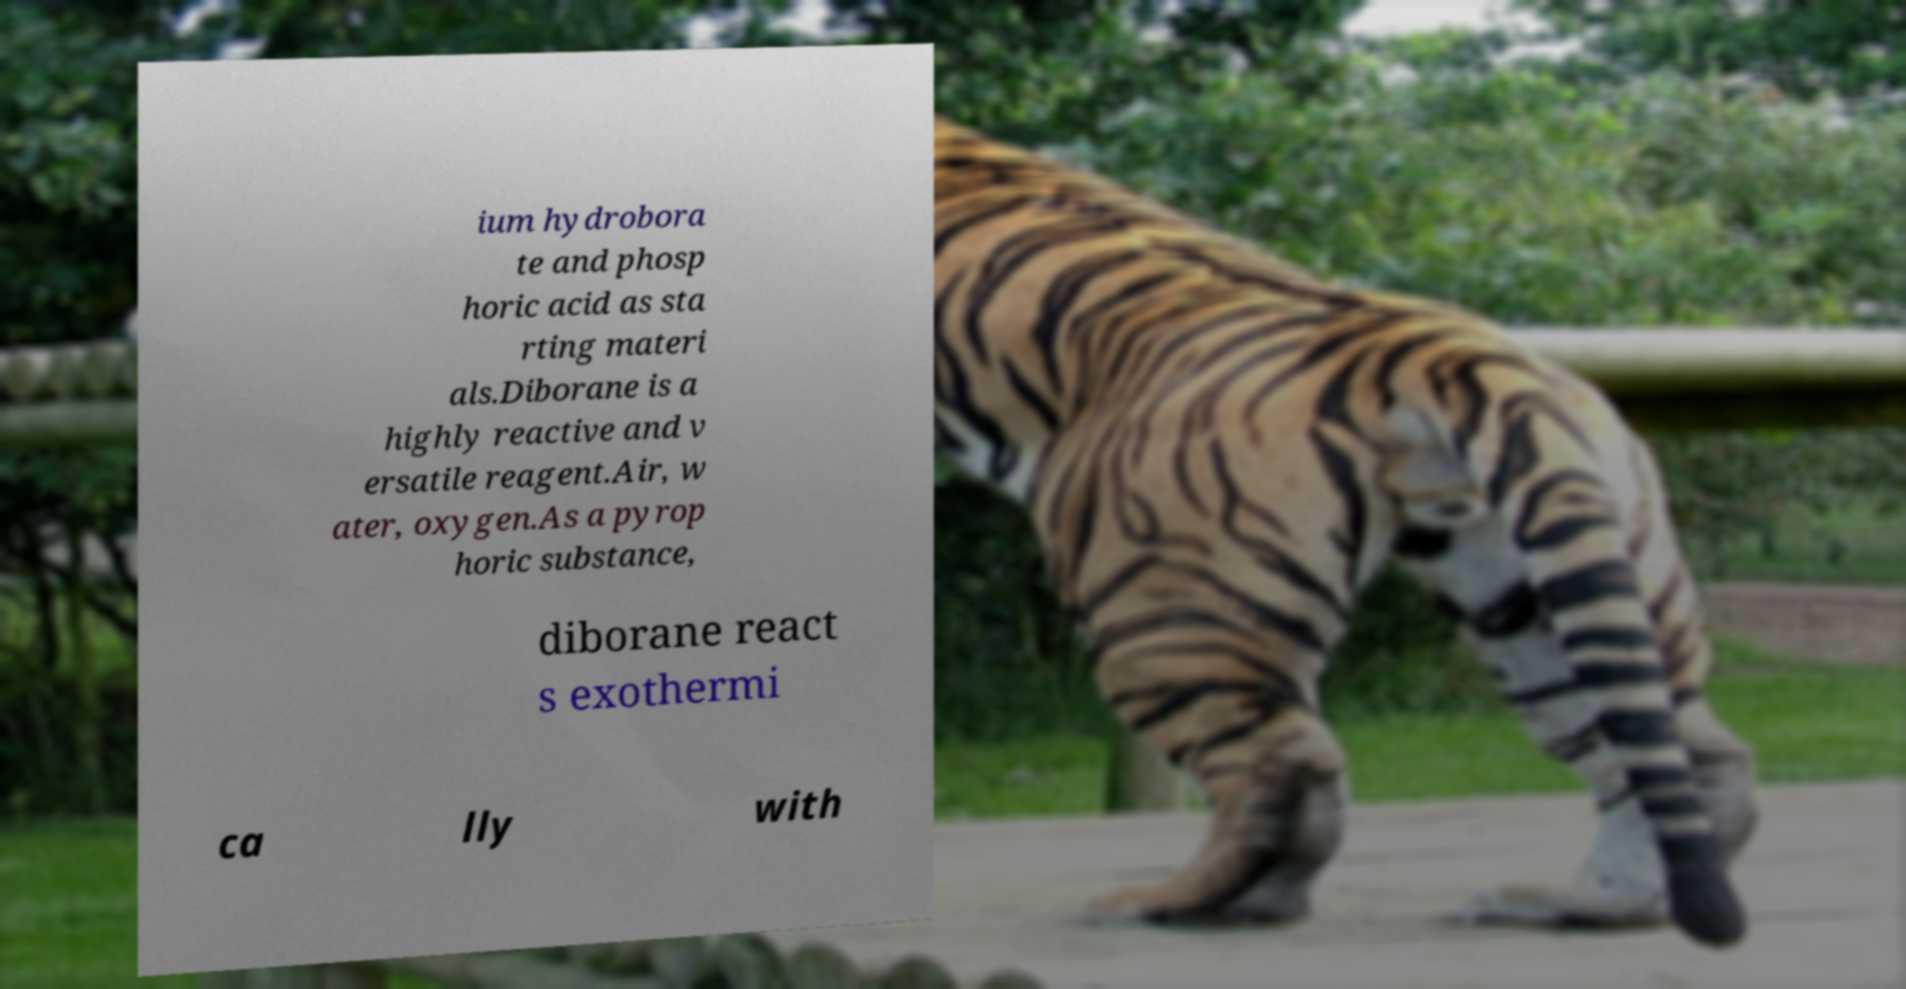Can you read and provide the text displayed in the image?This photo seems to have some interesting text. Can you extract and type it out for me? ium hydrobora te and phosp horic acid as sta rting materi als.Diborane is a highly reactive and v ersatile reagent.Air, w ater, oxygen.As a pyrop horic substance, diborane react s exothermi ca lly with 